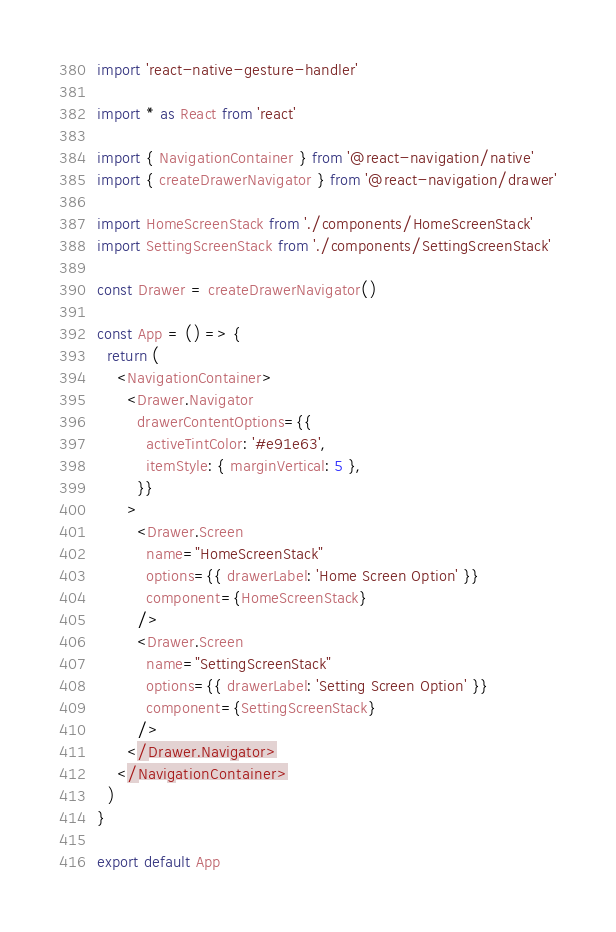Convert code to text. <code><loc_0><loc_0><loc_500><loc_500><_JavaScript_>import 'react-native-gesture-handler'

import * as React from 'react'

import { NavigationContainer } from '@react-navigation/native'
import { createDrawerNavigator } from '@react-navigation/drawer'

import HomeScreenStack from './components/HomeScreenStack'
import SettingScreenStack from './components/SettingScreenStack'

const Drawer = createDrawerNavigator()

const App = () => {
  return (
    <NavigationContainer>
      <Drawer.Navigator
        drawerContentOptions={{
          activeTintColor: '#e91e63',
          itemStyle: { marginVertical: 5 },
        }}
      >
        <Drawer.Screen
          name="HomeScreenStack"
          options={{ drawerLabel: 'Home Screen Option' }}
          component={HomeScreenStack}
        />
        <Drawer.Screen
          name="SettingScreenStack"
          options={{ drawerLabel: 'Setting Screen Option' }}
          component={SettingScreenStack}
        />
      </Drawer.Navigator>
    </NavigationContainer>
  )
}

export default App
</code> 